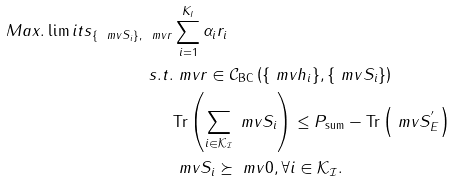Convert formula to latex. <formula><loc_0><loc_0><loc_500><loc_500>M a x . \lim i t s _ { \left \{ \ m v { S } _ { i } \right \} , \ m v { r } } & \sum ^ { K _ { I } } _ { i = 1 } \alpha _ { i } r _ { i } \\ s . t . & \ m v { r } \in \mathcal { C } _ { \text {BC} } \left ( \{ \ m v { h } _ { i } \} , \{ \ m v { S } _ { i } \} \right ) \\ & \text {Tr} \left ( \sum _ { i \in \mathcal { K _ { I } } } \ m v { S } _ { i } \right ) \leq P _ { \text {sum} } - \text {Tr} \left ( \ m v { S } ^ { ^ { \prime } } _ { E } \right ) \\ & \ m v { S } _ { i } \succeq \ m v { 0 } , \forall i \in \mathcal { K _ { I } } .</formula> 